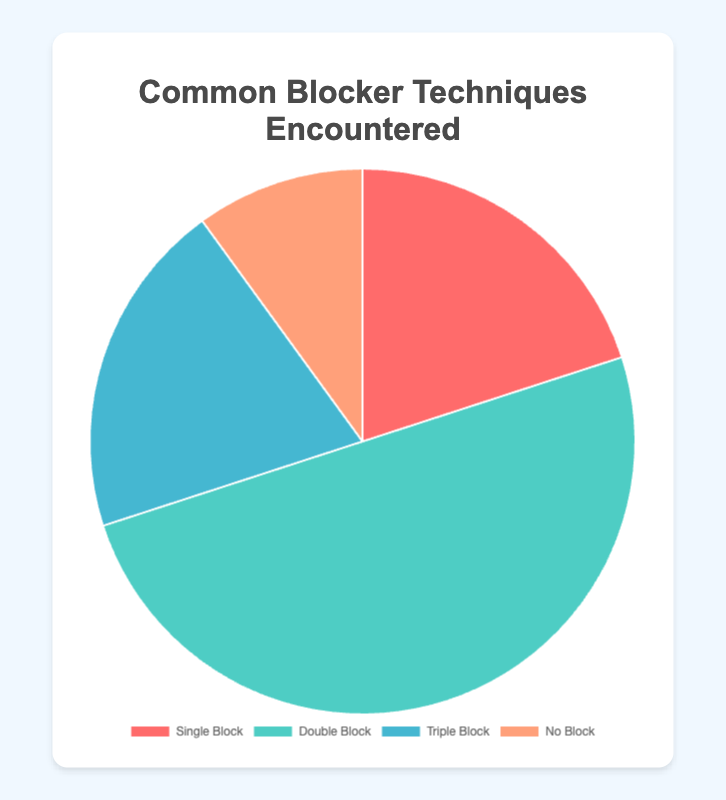What percentage of encounters are with no blockers? The data shows that 10% of the encounters involved no blockers.
Answer: 10% Which blocking technique is encountered the most? By comparing the percentages, Double Block is the highest with 50%.
Answer: Double Block What is the combined percentage of Single Block and Triple Block encounters? Adding the percentages of Single Block (20%) and Triple Block (20%), the total is 40%.
Answer: 40% How does the frequency of Single Block compare to Triple Block? Both Single Block and Triple Block have the same percentage, 20%.
Answer: Equal Which color represents the Double Block encounters in the pie chart? The Double Block slice is colored green in the visual representation.
Answer: Green What is the visual proportion of No Block encounters compared to Double Block encounters? No Block encounters form 10% of the chart, while Double Block encounters form 50%, making No Block one-fifth of Double Block.
Answer: One-fifth If Single Block and No Block encounters are combined, how do they compare percentage-wise to Double Block encounters? Single Block (20%) combined with No Block (10%) equals 30%, which is less than Double Block (50%).
Answer: Less than Double Block What fraction of the overall encounters are either Single or Double Blocks? Adding Single Block (20%) and Double Block (50%) gives 70%, which is 7/10 of the total encounters.
Answer: 7/10 Which blocking technique is the least encountered? No Block encounters are the least with 10%.
Answer: No Block 